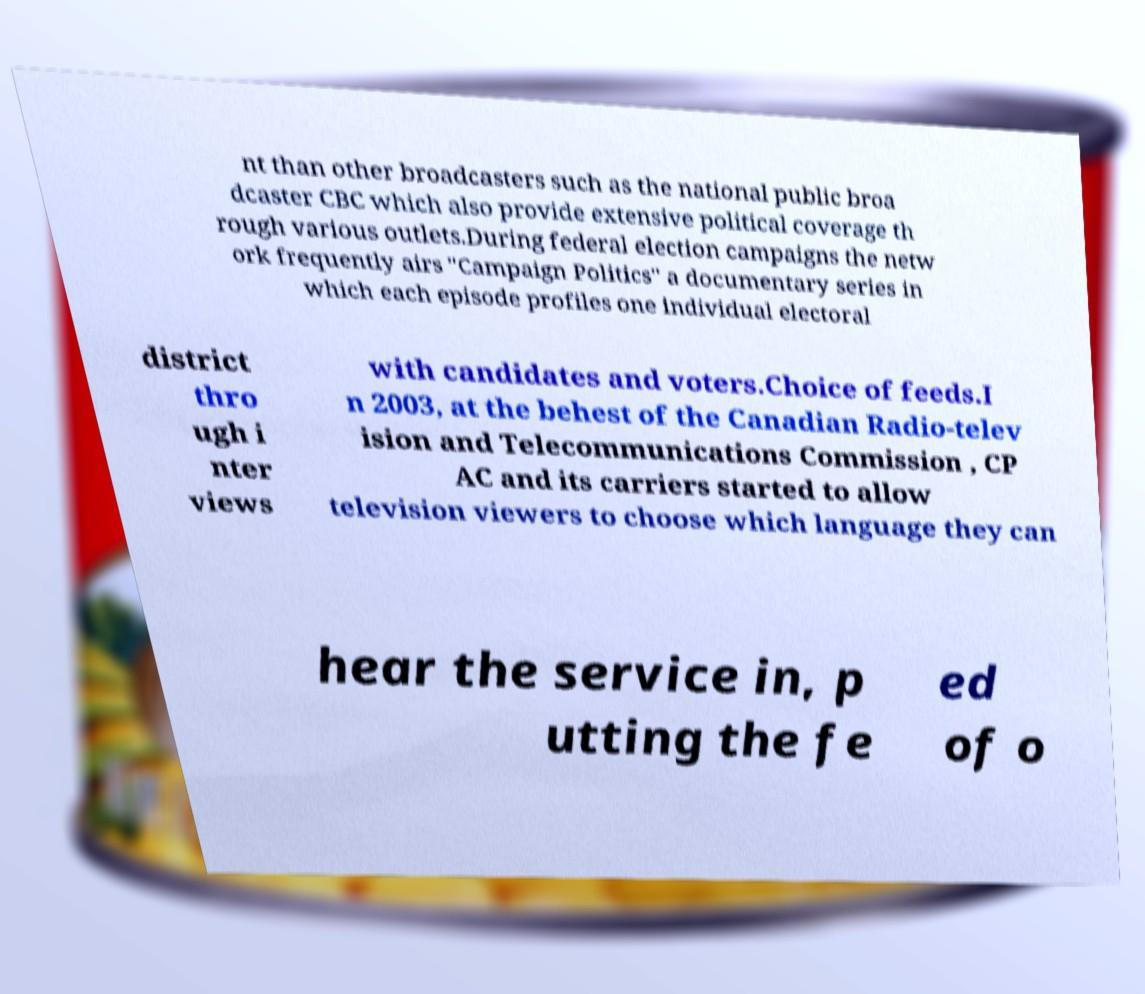For documentation purposes, I need the text within this image transcribed. Could you provide that? nt than other broadcasters such as the national public broa dcaster CBC which also provide extensive political coverage th rough various outlets.During federal election campaigns the netw ork frequently airs "Campaign Politics" a documentary series in which each episode profiles one individual electoral district thro ugh i nter views with candidates and voters.Choice of feeds.I n 2003, at the behest of the Canadian Radio-telev ision and Telecommunications Commission , CP AC and its carriers started to allow television viewers to choose which language they can hear the service in, p utting the fe ed of o 